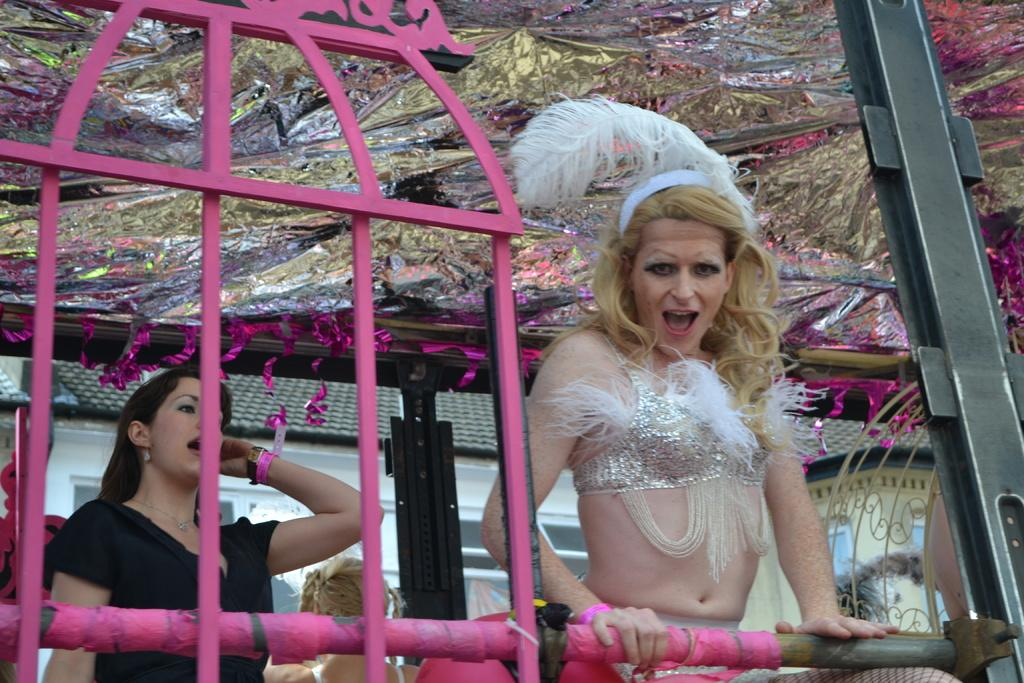How many people are present in the image? There are two women in the image. What can be seen in the background of the image? There is a house in the background of the image. What type of arch can be seen in the image? There is no arch present in the image; it only features two women and a house in the background. What time of day is it in the image, given the presence of a bucket? There is no bucket present in the image, so it is not possible to determine the time of day based on that object. 